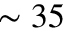<formula> <loc_0><loc_0><loc_500><loc_500>\sim 3 5</formula> 